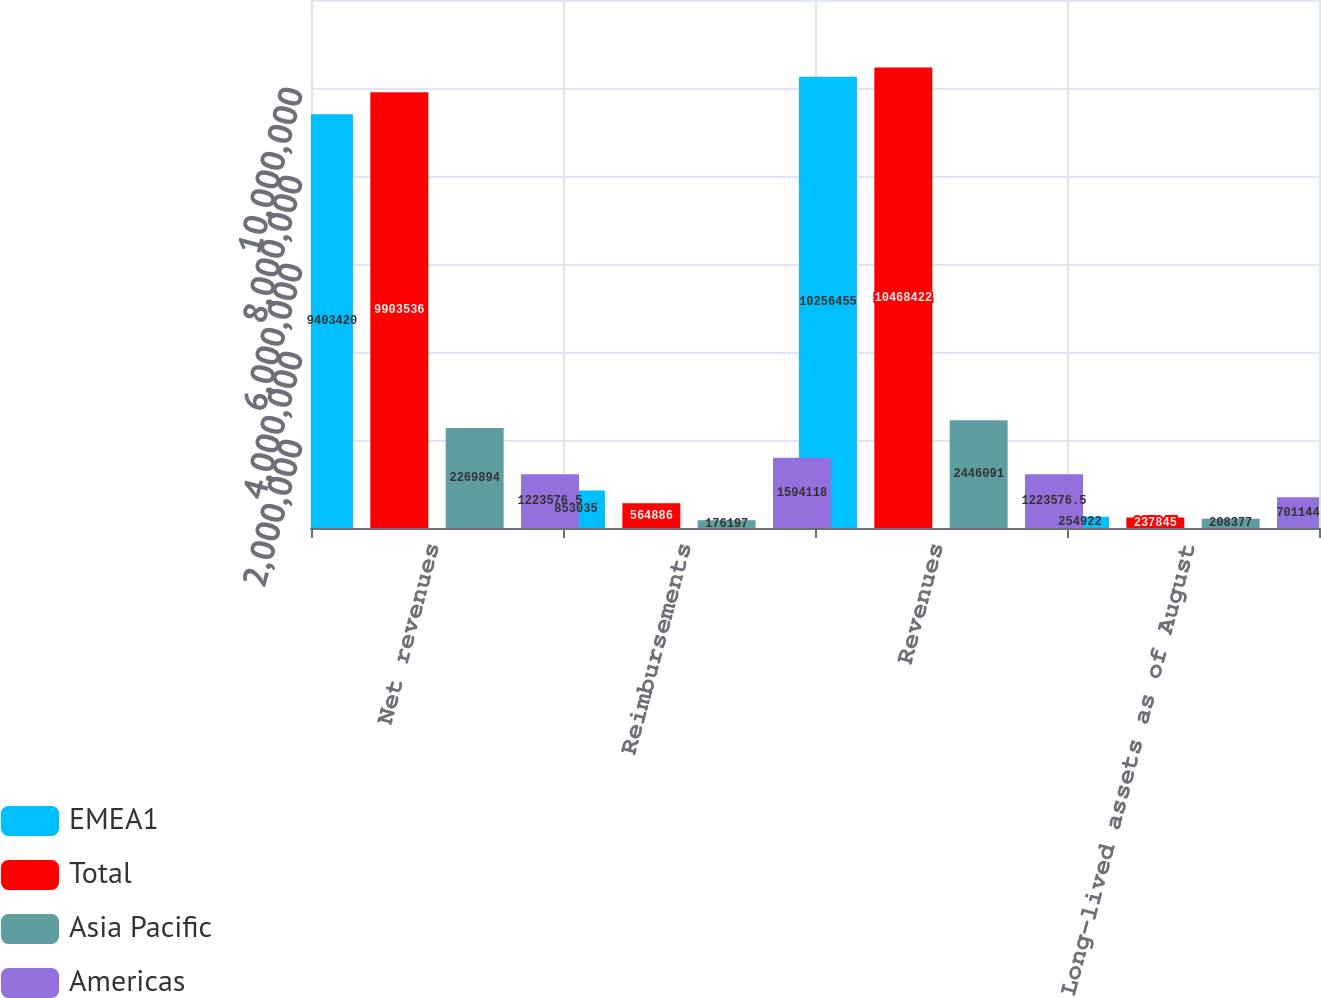Convert chart to OTSL. <chart><loc_0><loc_0><loc_500><loc_500><stacked_bar_chart><ecel><fcel>Net revenues<fcel>Reimbursements<fcel>Revenues<fcel>Long-lived assets as of August<nl><fcel>EMEA1<fcel>9.40342e+06<fcel>853035<fcel>1.02565e+07<fcel>254922<nl><fcel>Total<fcel>9.90354e+06<fcel>564886<fcel>1.04684e+07<fcel>237845<nl><fcel>Asia Pacific<fcel>2.26989e+06<fcel>176197<fcel>2.44609e+06<fcel>208377<nl><fcel>Americas<fcel>1.22358e+06<fcel>1.59412e+06<fcel>1.22358e+06<fcel>701144<nl></chart> 